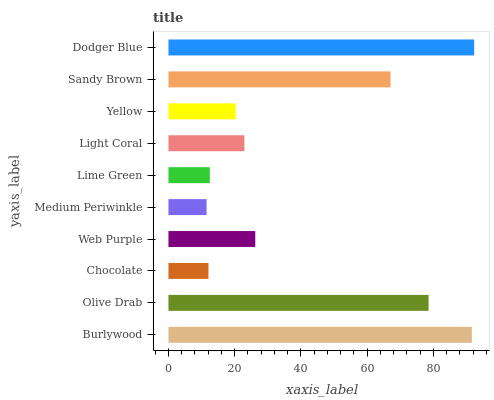Is Medium Periwinkle the minimum?
Answer yes or no. Yes. Is Dodger Blue the maximum?
Answer yes or no. Yes. Is Olive Drab the minimum?
Answer yes or no. No. Is Olive Drab the maximum?
Answer yes or no. No. Is Burlywood greater than Olive Drab?
Answer yes or no. Yes. Is Olive Drab less than Burlywood?
Answer yes or no. Yes. Is Olive Drab greater than Burlywood?
Answer yes or no. No. Is Burlywood less than Olive Drab?
Answer yes or no. No. Is Web Purple the high median?
Answer yes or no. Yes. Is Light Coral the low median?
Answer yes or no. Yes. Is Lime Green the high median?
Answer yes or no. No. Is Yellow the low median?
Answer yes or no. No. 